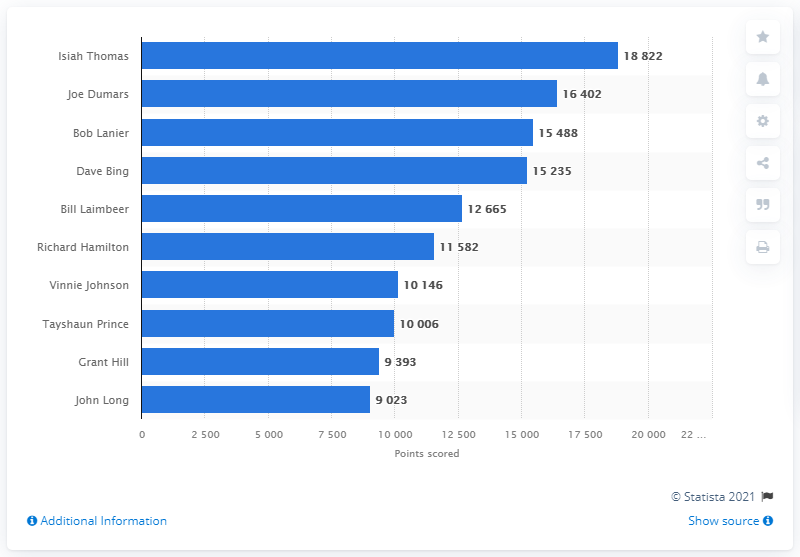List a handful of essential elements in this visual. Isiah Thomas is the career points leader of the Detroit Pistons. 